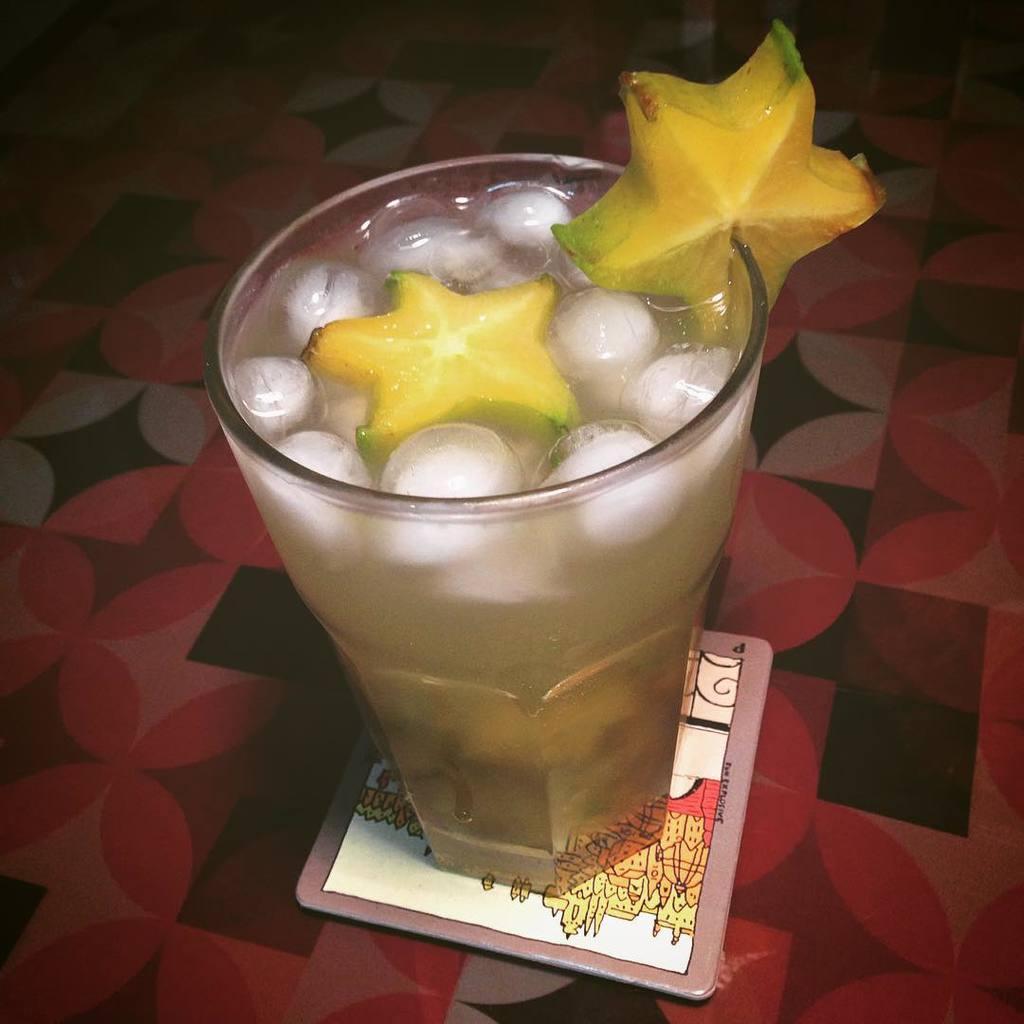Describe this image in one or two sentences. In the center of the picture there is a glass, in the glass there is drink with ice cubes and a fruit. At the bottom it is table. 